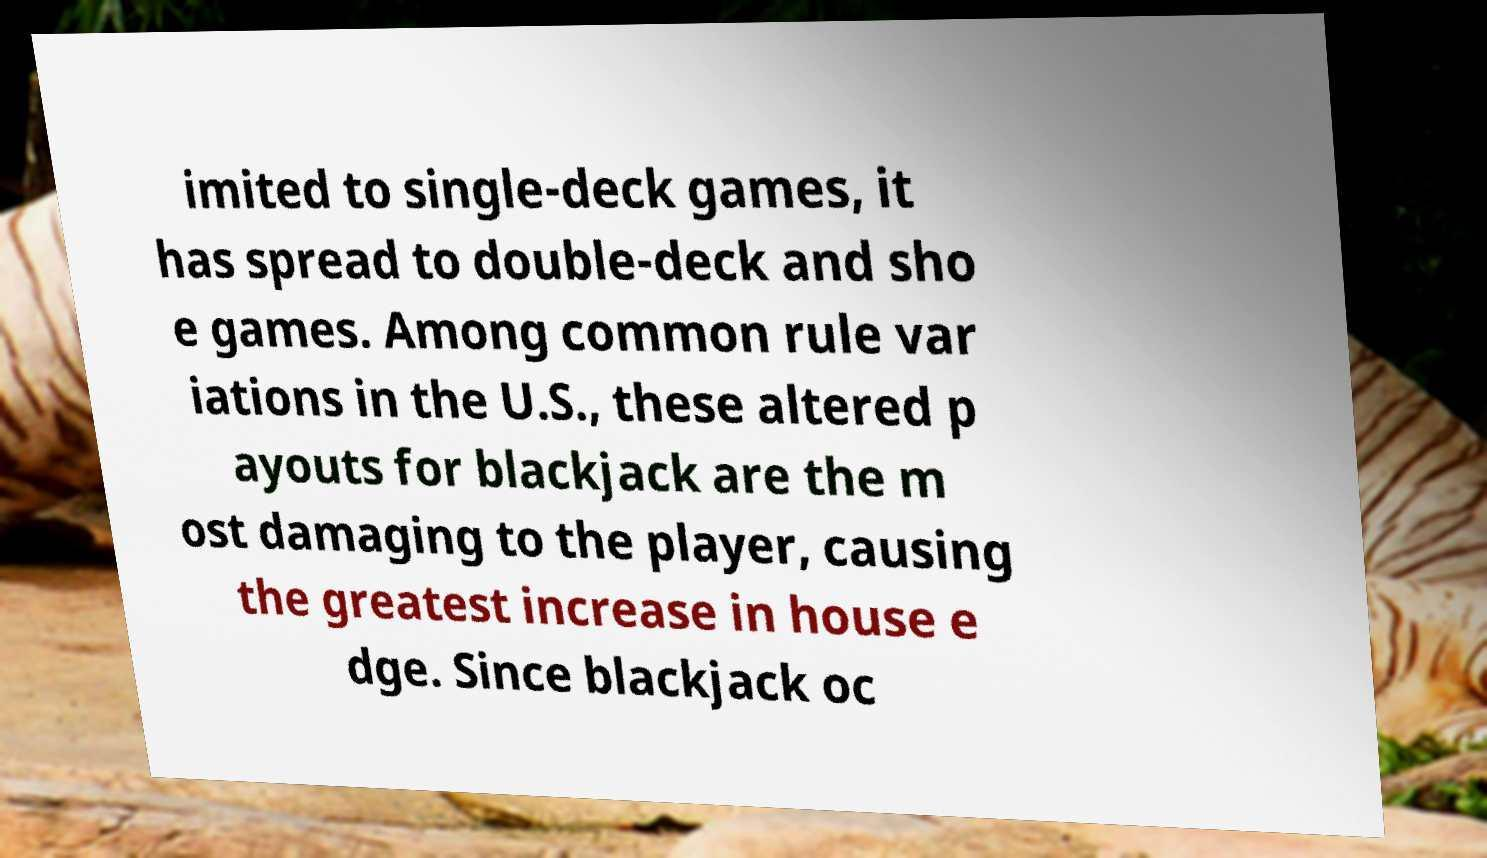For documentation purposes, I need the text within this image transcribed. Could you provide that? imited to single-deck games, it has spread to double-deck and sho e games. Among common rule var iations in the U.S., these altered p ayouts for blackjack are the m ost damaging to the player, causing the greatest increase in house e dge. Since blackjack oc 